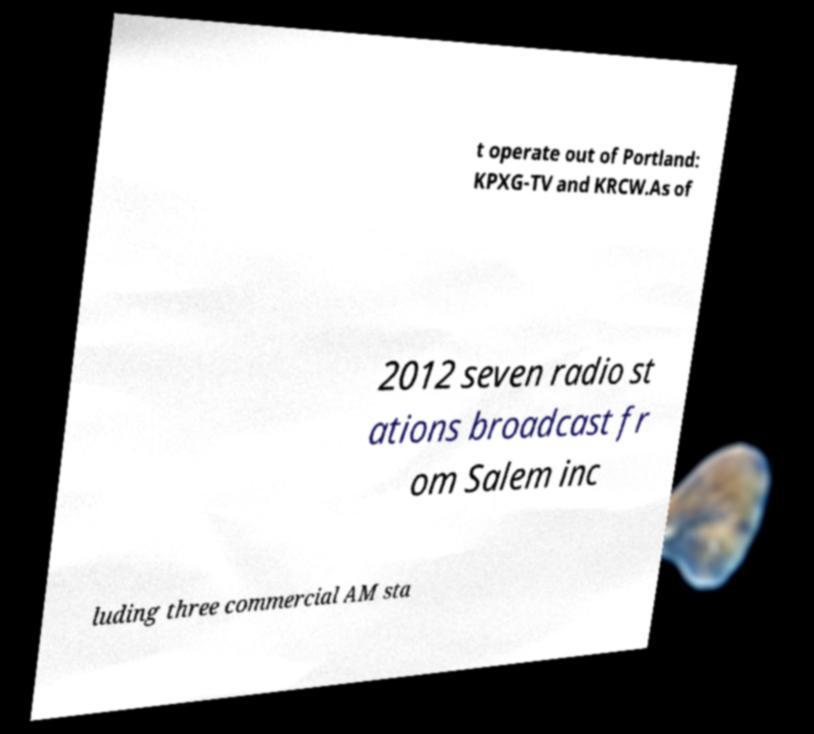Could you extract and type out the text from this image? t operate out of Portland: KPXG-TV and KRCW.As of 2012 seven radio st ations broadcast fr om Salem inc luding three commercial AM sta 